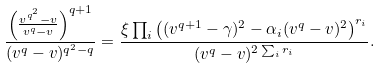<formula> <loc_0><loc_0><loc_500><loc_500>\frac { \left ( \frac { { v ^ { q ^ { 2 } } - v } } { v ^ { q } - v } \right ) ^ { q + 1 } } { ( v ^ { q } - v ) ^ { q ^ { 2 } - q } } = \frac { \xi \prod _ { i } \left ( ( v ^ { q + 1 } - \gamma ) ^ { 2 } - \alpha _ { i } ( v ^ { q } - v ) ^ { 2 } \right ) ^ { r _ { i } } } { ( v ^ { q } - v ) ^ { 2 \sum _ { i } r _ { i } } } .</formula> 